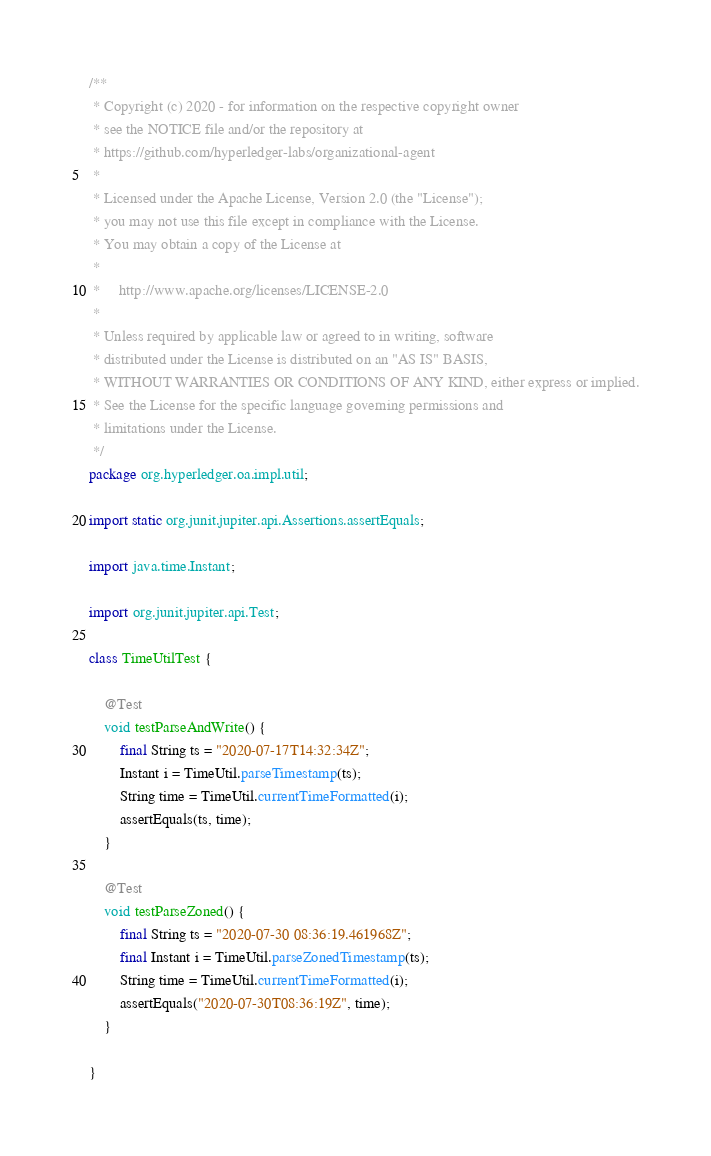Convert code to text. <code><loc_0><loc_0><loc_500><loc_500><_Java_>/**
 * Copyright (c) 2020 - for information on the respective copyright owner
 * see the NOTICE file and/or the repository at
 * https://github.com/hyperledger-labs/organizational-agent
 *
 * Licensed under the Apache License, Version 2.0 (the "License");
 * you may not use this file except in compliance with the License.
 * You may obtain a copy of the License at
 *
 *     http://www.apache.org/licenses/LICENSE-2.0
 *
 * Unless required by applicable law or agreed to in writing, software
 * distributed under the License is distributed on an "AS IS" BASIS,
 * WITHOUT WARRANTIES OR CONDITIONS OF ANY KIND, either express or implied.
 * See the License for the specific language governing permissions and
 * limitations under the License.
 */
package org.hyperledger.oa.impl.util;

import static org.junit.jupiter.api.Assertions.assertEquals;

import java.time.Instant;

import org.junit.jupiter.api.Test;

class TimeUtilTest {

    @Test
    void testParseAndWrite() {
        final String ts = "2020-07-17T14:32:34Z";
        Instant i = TimeUtil.parseTimestamp(ts);
        String time = TimeUtil.currentTimeFormatted(i);
        assertEquals(ts, time);
    }

    @Test
    void testParseZoned() {
        final String ts = "2020-07-30 08:36:19.461968Z";
        final Instant i = TimeUtil.parseZonedTimestamp(ts);
        String time = TimeUtil.currentTimeFormatted(i);
        assertEquals("2020-07-30T08:36:19Z", time);
    }

}
</code> 